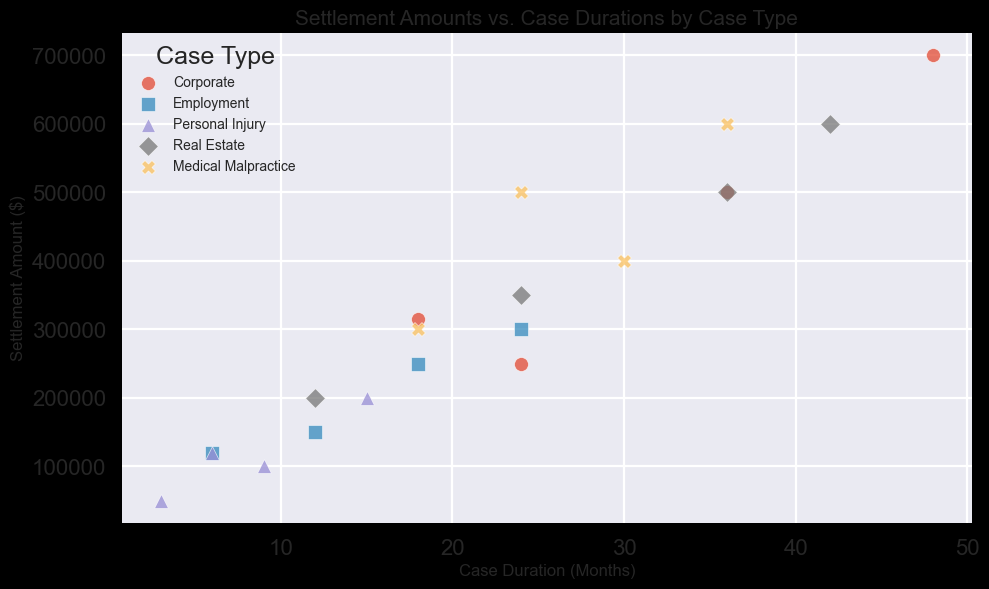What is the total settlement amount for Employment cases? Employment cases have settlement amounts of 150000, 300000, 120000, and 250000. Summing these values: 150000 + 300000 + 120000 + 250000 = 820000
Answer: 820000 Which case type has the highest settlement amount, and what is it? The scatter plot shows various markers indicating their settlement amounts. By viewing the highest point, it is seen that the "Corporate" case type has a point at 700000, which is the highest.
Answer: Corporate, 700000 How many Corporate cases lasted more than 30 months? To find this, we look at the markers for Corporate cases and count those where the x-axis value (Case Duration) is greater than 30. There are 2 such cases: one at 36 months and another at 48 months.
Answer: 2 What is the average settlement amount for Real Estate cases? Real Estate cases have settlement amounts of 350000, 500000, 200000, and 600000. The sum is 350000 + 500000 + 200000 + 600000 = 1650000. Since there are 4 cases, the average is 1650000 / 4 = 412500
Answer: 412500 Compare the median case duration for Medical Malpractice and Personal Injury cases. Which one is higher and by how much? The durations for Medical Malpractice are 30, 18, 36, and 24 months. The median is the average of 24 and 30, which is (24 + 30) / 2 = 27. The durations for Personal Injury are 9, 3, 15, and 6 months, with a median of (6 + 9) / 2 = 7.5. The difference is 27 - 7.5 = 19.5
Answer: Medical Malpractice, 19.5 Which case type shows the least variance in settlement amounts? By visually inspecting the range of settlement amounts for each case type, it appears that "Personal Injury" cases have the least variance, as the settlement amounts are closely clustered together compared to other groups.
Answer: Personal Injury Is there a noticeable trend between case duration and settlement amount for Real Estate cases? Real Estate cases seem to show a positive correlation between case duration and settlement amount; longer case durations correspond to higher settlement amounts, observable from the increasing pattern of the plotted points.
Answer: Yes, positive correlation Which case type has the most cases plotted on the scatter plot? By counting the markers, "Employment" appears to have 4 points, "Corporate" has 4, "Personal Injury" has 4, "Real Estate" has 4, and "Medical Malpractice" has 4. All case types have an equal number of plotted points.
Answer: All case types (Equal) What is the visual characteristic that differentiates Employment case settlements from Medical Malpractice on the plot? Employment case settlements are represented by square (s) markers, while Medical Malpractice is represented by x (X) markers. This differentiation in marker shape helps visually distinguish between the two case types on the scatter plot.
Answer: Marker shape: Square vs X 